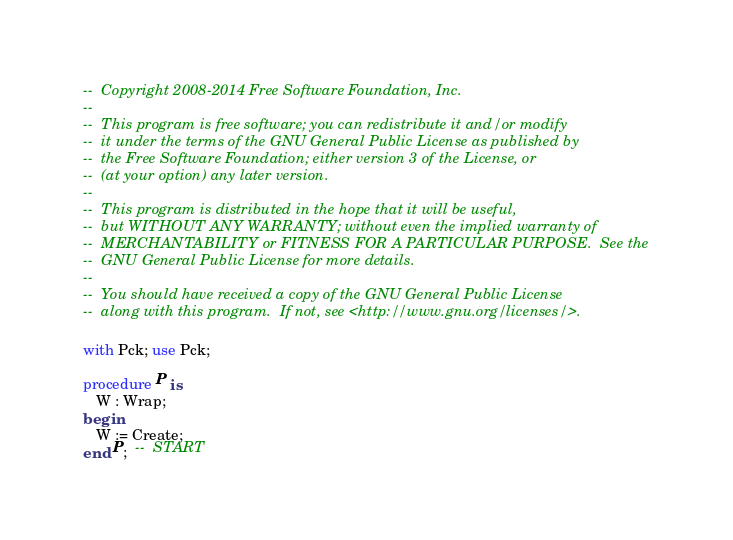<code> <loc_0><loc_0><loc_500><loc_500><_Ada_>--  Copyright 2008-2014 Free Software Foundation, Inc.
--
--  This program is free software; you can redistribute it and/or modify
--  it under the terms of the GNU General Public License as published by
--  the Free Software Foundation; either version 3 of the License, or
--  (at your option) any later version.
--
--  This program is distributed in the hope that it will be useful,
--  but WITHOUT ANY WARRANTY; without even the implied warranty of
--  MERCHANTABILITY or FITNESS FOR A PARTICULAR PURPOSE.  See the
--  GNU General Public License for more details.
--
--  You should have received a copy of the GNU General Public License
--  along with this program.  If not, see <http://www.gnu.org/licenses/>.

with Pck; use Pck;

procedure P is
   W : Wrap;
begin
   W := Create;
end P;  --  START

</code> 